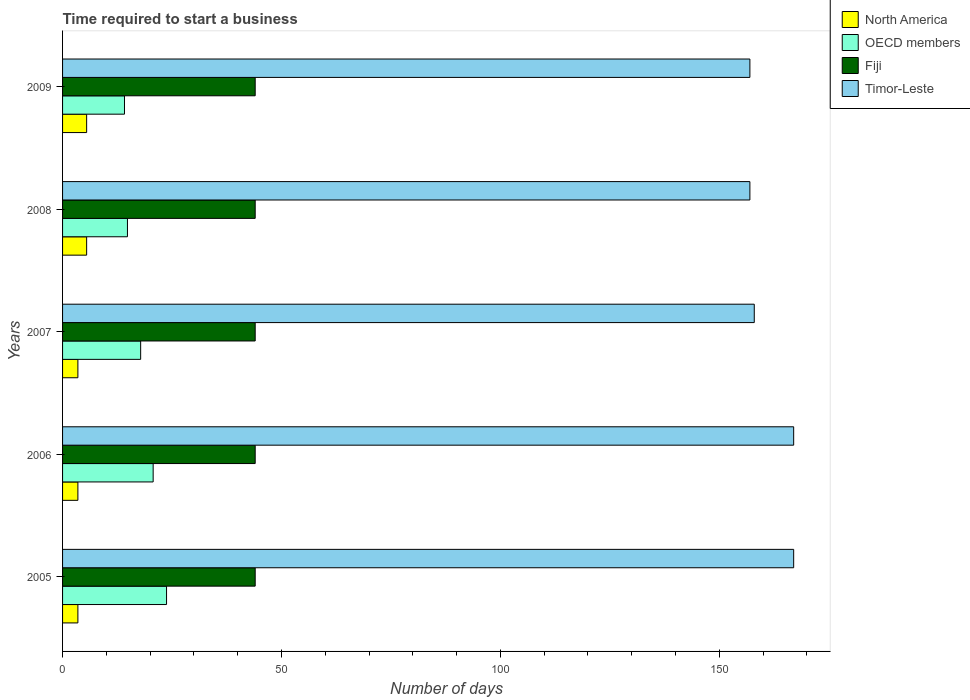How many different coloured bars are there?
Ensure brevity in your answer.  4. How many groups of bars are there?
Make the answer very short. 5. How many bars are there on the 5th tick from the top?
Provide a short and direct response. 4. What is the label of the 2nd group of bars from the top?
Your answer should be very brief. 2008. What is the number of days required to start a business in North America in 2008?
Your answer should be very brief. 5.5. Across all years, what is the maximum number of days required to start a business in Fiji?
Make the answer very short. 44. Across all years, what is the minimum number of days required to start a business in Fiji?
Your answer should be compact. 44. In which year was the number of days required to start a business in Fiji maximum?
Your answer should be compact. 2005. What is the total number of days required to start a business in Timor-Leste in the graph?
Your answer should be compact. 806. What is the difference between the number of days required to start a business in North America in 2005 and that in 2009?
Ensure brevity in your answer.  -2. What is the difference between the number of days required to start a business in OECD members in 2009 and the number of days required to start a business in Fiji in 2008?
Your answer should be very brief. -29.85. What is the average number of days required to start a business in Timor-Leste per year?
Provide a succinct answer. 161.2. In the year 2008, what is the difference between the number of days required to start a business in North America and number of days required to start a business in Timor-Leste?
Ensure brevity in your answer.  -151.5. In how many years, is the number of days required to start a business in Timor-Leste greater than 160 days?
Your answer should be very brief. 2. What is the ratio of the number of days required to start a business in OECD members in 2006 to that in 2007?
Ensure brevity in your answer.  1.16. Is the difference between the number of days required to start a business in North America in 2005 and 2007 greater than the difference between the number of days required to start a business in Timor-Leste in 2005 and 2007?
Ensure brevity in your answer.  No. What is the difference between the highest and the second highest number of days required to start a business in OECD members?
Offer a terse response. 3.06. What is the difference between the highest and the lowest number of days required to start a business in North America?
Your answer should be compact. 2. Is it the case that in every year, the sum of the number of days required to start a business in Fiji and number of days required to start a business in Timor-Leste is greater than the sum of number of days required to start a business in OECD members and number of days required to start a business in North America?
Give a very brief answer. No. What does the 1st bar from the top in 2007 represents?
Provide a succinct answer. Timor-Leste. What does the 4th bar from the bottom in 2006 represents?
Your response must be concise. Timor-Leste. Is it the case that in every year, the sum of the number of days required to start a business in North America and number of days required to start a business in OECD members is greater than the number of days required to start a business in Timor-Leste?
Your answer should be very brief. No. Are all the bars in the graph horizontal?
Your response must be concise. Yes. How many years are there in the graph?
Offer a terse response. 5. What is the difference between two consecutive major ticks on the X-axis?
Offer a terse response. 50. Does the graph contain any zero values?
Make the answer very short. No. Does the graph contain grids?
Provide a succinct answer. No. What is the title of the graph?
Provide a short and direct response. Time required to start a business. Does "Marshall Islands" appear as one of the legend labels in the graph?
Your response must be concise. No. What is the label or title of the X-axis?
Give a very brief answer. Number of days. What is the label or title of the Y-axis?
Provide a short and direct response. Years. What is the Number of days in OECD members in 2005?
Your answer should be compact. 23.75. What is the Number of days of Timor-Leste in 2005?
Provide a short and direct response. 167. What is the Number of days in OECD members in 2006?
Provide a succinct answer. 20.69. What is the Number of days in Fiji in 2006?
Make the answer very short. 44. What is the Number of days of Timor-Leste in 2006?
Keep it short and to the point. 167. What is the Number of days in North America in 2007?
Offer a very short reply. 3.5. What is the Number of days in OECD members in 2007?
Ensure brevity in your answer.  17.84. What is the Number of days in Fiji in 2007?
Your answer should be very brief. 44. What is the Number of days of Timor-Leste in 2007?
Make the answer very short. 158. What is the Number of days of OECD members in 2008?
Make the answer very short. 14.82. What is the Number of days in Fiji in 2008?
Keep it short and to the point. 44. What is the Number of days in Timor-Leste in 2008?
Provide a short and direct response. 157. What is the Number of days of OECD members in 2009?
Provide a short and direct response. 14.15. What is the Number of days of Timor-Leste in 2009?
Ensure brevity in your answer.  157. Across all years, what is the maximum Number of days in North America?
Your response must be concise. 5.5. Across all years, what is the maximum Number of days of OECD members?
Ensure brevity in your answer.  23.75. Across all years, what is the maximum Number of days in Timor-Leste?
Offer a very short reply. 167. Across all years, what is the minimum Number of days in OECD members?
Ensure brevity in your answer.  14.15. Across all years, what is the minimum Number of days in Timor-Leste?
Your response must be concise. 157. What is the total Number of days of North America in the graph?
Give a very brief answer. 21.5. What is the total Number of days in OECD members in the graph?
Provide a short and direct response. 91.25. What is the total Number of days in Fiji in the graph?
Ensure brevity in your answer.  220. What is the total Number of days of Timor-Leste in the graph?
Give a very brief answer. 806. What is the difference between the Number of days of OECD members in 2005 and that in 2006?
Offer a terse response. 3.06. What is the difference between the Number of days of Fiji in 2005 and that in 2006?
Offer a terse response. 0. What is the difference between the Number of days of Timor-Leste in 2005 and that in 2006?
Your answer should be very brief. 0. What is the difference between the Number of days of North America in 2005 and that in 2007?
Ensure brevity in your answer.  0. What is the difference between the Number of days in OECD members in 2005 and that in 2007?
Your answer should be very brief. 5.91. What is the difference between the Number of days of Fiji in 2005 and that in 2007?
Provide a succinct answer. 0. What is the difference between the Number of days in North America in 2005 and that in 2008?
Offer a very short reply. -2. What is the difference between the Number of days of OECD members in 2005 and that in 2008?
Your response must be concise. 8.93. What is the difference between the Number of days in Fiji in 2005 and that in 2008?
Ensure brevity in your answer.  0. What is the difference between the Number of days in Timor-Leste in 2005 and that in 2008?
Your answer should be very brief. 10. What is the difference between the Number of days in North America in 2005 and that in 2009?
Offer a terse response. -2. What is the difference between the Number of days in OECD members in 2005 and that in 2009?
Your answer should be very brief. 9.6. What is the difference between the Number of days in Fiji in 2005 and that in 2009?
Offer a terse response. 0. What is the difference between the Number of days of Timor-Leste in 2005 and that in 2009?
Your answer should be very brief. 10. What is the difference between the Number of days of North America in 2006 and that in 2007?
Your answer should be very brief. 0. What is the difference between the Number of days in OECD members in 2006 and that in 2007?
Your answer should be compact. 2.85. What is the difference between the Number of days of Timor-Leste in 2006 and that in 2007?
Your response must be concise. 9. What is the difference between the Number of days in OECD members in 2006 and that in 2008?
Provide a short and direct response. 5.87. What is the difference between the Number of days in Fiji in 2006 and that in 2008?
Your answer should be compact. 0. What is the difference between the Number of days in North America in 2006 and that in 2009?
Ensure brevity in your answer.  -2. What is the difference between the Number of days of OECD members in 2006 and that in 2009?
Your response must be concise. 6.55. What is the difference between the Number of days of Fiji in 2006 and that in 2009?
Offer a very short reply. 0. What is the difference between the Number of days in Timor-Leste in 2006 and that in 2009?
Your answer should be compact. 10. What is the difference between the Number of days of OECD members in 2007 and that in 2008?
Offer a terse response. 3.02. What is the difference between the Number of days in North America in 2007 and that in 2009?
Provide a succinct answer. -2. What is the difference between the Number of days of OECD members in 2007 and that in 2009?
Keep it short and to the point. 3.69. What is the difference between the Number of days in North America in 2008 and that in 2009?
Your answer should be very brief. 0. What is the difference between the Number of days of OECD members in 2008 and that in 2009?
Offer a very short reply. 0.68. What is the difference between the Number of days of Fiji in 2008 and that in 2009?
Give a very brief answer. 0. What is the difference between the Number of days of North America in 2005 and the Number of days of OECD members in 2006?
Give a very brief answer. -17.19. What is the difference between the Number of days in North America in 2005 and the Number of days in Fiji in 2006?
Ensure brevity in your answer.  -40.5. What is the difference between the Number of days of North America in 2005 and the Number of days of Timor-Leste in 2006?
Provide a succinct answer. -163.5. What is the difference between the Number of days in OECD members in 2005 and the Number of days in Fiji in 2006?
Provide a short and direct response. -20.25. What is the difference between the Number of days of OECD members in 2005 and the Number of days of Timor-Leste in 2006?
Your answer should be compact. -143.25. What is the difference between the Number of days of Fiji in 2005 and the Number of days of Timor-Leste in 2006?
Make the answer very short. -123. What is the difference between the Number of days of North America in 2005 and the Number of days of OECD members in 2007?
Your answer should be compact. -14.34. What is the difference between the Number of days in North America in 2005 and the Number of days in Fiji in 2007?
Offer a very short reply. -40.5. What is the difference between the Number of days in North America in 2005 and the Number of days in Timor-Leste in 2007?
Provide a short and direct response. -154.5. What is the difference between the Number of days of OECD members in 2005 and the Number of days of Fiji in 2007?
Ensure brevity in your answer.  -20.25. What is the difference between the Number of days in OECD members in 2005 and the Number of days in Timor-Leste in 2007?
Ensure brevity in your answer.  -134.25. What is the difference between the Number of days of Fiji in 2005 and the Number of days of Timor-Leste in 2007?
Offer a very short reply. -114. What is the difference between the Number of days in North America in 2005 and the Number of days in OECD members in 2008?
Offer a terse response. -11.32. What is the difference between the Number of days of North America in 2005 and the Number of days of Fiji in 2008?
Give a very brief answer. -40.5. What is the difference between the Number of days of North America in 2005 and the Number of days of Timor-Leste in 2008?
Offer a very short reply. -153.5. What is the difference between the Number of days in OECD members in 2005 and the Number of days in Fiji in 2008?
Your response must be concise. -20.25. What is the difference between the Number of days in OECD members in 2005 and the Number of days in Timor-Leste in 2008?
Your response must be concise. -133.25. What is the difference between the Number of days of Fiji in 2005 and the Number of days of Timor-Leste in 2008?
Your response must be concise. -113. What is the difference between the Number of days of North America in 2005 and the Number of days of OECD members in 2009?
Make the answer very short. -10.65. What is the difference between the Number of days of North America in 2005 and the Number of days of Fiji in 2009?
Provide a short and direct response. -40.5. What is the difference between the Number of days of North America in 2005 and the Number of days of Timor-Leste in 2009?
Your response must be concise. -153.5. What is the difference between the Number of days of OECD members in 2005 and the Number of days of Fiji in 2009?
Provide a succinct answer. -20.25. What is the difference between the Number of days of OECD members in 2005 and the Number of days of Timor-Leste in 2009?
Offer a very short reply. -133.25. What is the difference between the Number of days of Fiji in 2005 and the Number of days of Timor-Leste in 2009?
Provide a short and direct response. -113. What is the difference between the Number of days in North America in 2006 and the Number of days in OECD members in 2007?
Make the answer very short. -14.34. What is the difference between the Number of days of North America in 2006 and the Number of days of Fiji in 2007?
Offer a terse response. -40.5. What is the difference between the Number of days of North America in 2006 and the Number of days of Timor-Leste in 2007?
Make the answer very short. -154.5. What is the difference between the Number of days of OECD members in 2006 and the Number of days of Fiji in 2007?
Your response must be concise. -23.31. What is the difference between the Number of days in OECD members in 2006 and the Number of days in Timor-Leste in 2007?
Make the answer very short. -137.31. What is the difference between the Number of days in Fiji in 2006 and the Number of days in Timor-Leste in 2007?
Keep it short and to the point. -114. What is the difference between the Number of days in North America in 2006 and the Number of days in OECD members in 2008?
Ensure brevity in your answer.  -11.32. What is the difference between the Number of days of North America in 2006 and the Number of days of Fiji in 2008?
Make the answer very short. -40.5. What is the difference between the Number of days of North America in 2006 and the Number of days of Timor-Leste in 2008?
Your response must be concise. -153.5. What is the difference between the Number of days in OECD members in 2006 and the Number of days in Fiji in 2008?
Offer a terse response. -23.31. What is the difference between the Number of days of OECD members in 2006 and the Number of days of Timor-Leste in 2008?
Give a very brief answer. -136.31. What is the difference between the Number of days of Fiji in 2006 and the Number of days of Timor-Leste in 2008?
Offer a terse response. -113. What is the difference between the Number of days of North America in 2006 and the Number of days of OECD members in 2009?
Ensure brevity in your answer.  -10.65. What is the difference between the Number of days in North America in 2006 and the Number of days in Fiji in 2009?
Your answer should be compact. -40.5. What is the difference between the Number of days in North America in 2006 and the Number of days in Timor-Leste in 2009?
Make the answer very short. -153.5. What is the difference between the Number of days in OECD members in 2006 and the Number of days in Fiji in 2009?
Your answer should be compact. -23.31. What is the difference between the Number of days of OECD members in 2006 and the Number of days of Timor-Leste in 2009?
Ensure brevity in your answer.  -136.31. What is the difference between the Number of days of Fiji in 2006 and the Number of days of Timor-Leste in 2009?
Give a very brief answer. -113. What is the difference between the Number of days in North America in 2007 and the Number of days in OECD members in 2008?
Provide a succinct answer. -11.32. What is the difference between the Number of days in North America in 2007 and the Number of days in Fiji in 2008?
Offer a terse response. -40.5. What is the difference between the Number of days of North America in 2007 and the Number of days of Timor-Leste in 2008?
Make the answer very short. -153.5. What is the difference between the Number of days in OECD members in 2007 and the Number of days in Fiji in 2008?
Provide a short and direct response. -26.16. What is the difference between the Number of days of OECD members in 2007 and the Number of days of Timor-Leste in 2008?
Give a very brief answer. -139.16. What is the difference between the Number of days of Fiji in 2007 and the Number of days of Timor-Leste in 2008?
Provide a short and direct response. -113. What is the difference between the Number of days of North America in 2007 and the Number of days of OECD members in 2009?
Provide a succinct answer. -10.65. What is the difference between the Number of days in North America in 2007 and the Number of days in Fiji in 2009?
Make the answer very short. -40.5. What is the difference between the Number of days of North America in 2007 and the Number of days of Timor-Leste in 2009?
Your response must be concise. -153.5. What is the difference between the Number of days in OECD members in 2007 and the Number of days in Fiji in 2009?
Provide a succinct answer. -26.16. What is the difference between the Number of days of OECD members in 2007 and the Number of days of Timor-Leste in 2009?
Offer a terse response. -139.16. What is the difference between the Number of days in Fiji in 2007 and the Number of days in Timor-Leste in 2009?
Make the answer very short. -113. What is the difference between the Number of days in North America in 2008 and the Number of days in OECD members in 2009?
Your answer should be compact. -8.65. What is the difference between the Number of days of North America in 2008 and the Number of days of Fiji in 2009?
Provide a short and direct response. -38.5. What is the difference between the Number of days of North America in 2008 and the Number of days of Timor-Leste in 2009?
Give a very brief answer. -151.5. What is the difference between the Number of days in OECD members in 2008 and the Number of days in Fiji in 2009?
Your answer should be very brief. -29.18. What is the difference between the Number of days in OECD members in 2008 and the Number of days in Timor-Leste in 2009?
Offer a very short reply. -142.18. What is the difference between the Number of days of Fiji in 2008 and the Number of days of Timor-Leste in 2009?
Offer a very short reply. -113. What is the average Number of days of OECD members per year?
Give a very brief answer. 18.25. What is the average Number of days of Timor-Leste per year?
Your answer should be very brief. 161.2. In the year 2005, what is the difference between the Number of days of North America and Number of days of OECD members?
Provide a short and direct response. -20.25. In the year 2005, what is the difference between the Number of days of North America and Number of days of Fiji?
Offer a very short reply. -40.5. In the year 2005, what is the difference between the Number of days of North America and Number of days of Timor-Leste?
Offer a terse response. -163.5. In the year 2005, what is the difference between the Number of days of OECD members and Number of days of Fiji?
Ensure brevity in your answer.  -20.25. In the year 2005, what is the difference between the Number of days in OECD members and Number of days in Timor-Leste?
Keep it short and to the point. -143.25. In the year 2005, what is the difference between the Number of days in Fiji and Number of days in Timor-Leste?
Your answer should be very brief. -123. In the year 2006, what is the difference between the Number of days of North America and Number of days of OECD members?
Keep it short and to the point. -17.19. In the year 2006, what is the difference between the Number of days in North America and Number of days in Fiji?
Ensure brevity in your answer.  -40.5. In the year 2006, what is the difference between the Number of days of North America and Number of days of Timor-Leste?
Provide a short and direct response. -163.5. In the year 2006, what is the difference between the Number of days in OECD members and Number of days in Fiji?
Provide a short and direct response. -23.31. In the year 2006, what is the difference between the Number of days in OECD members and Number of days in Timor-Leste?
Offer a very short reply. -146.31. In the year 2006, what is the difference between the Number of days in Fiji and Number of days in Timor-Leste?
Ensure brevity in your answer.  -123. In the year 2007, what is the difference between the Number of days in North America and Number of days in OECD members?
Provide a short and direct response. -14.34. In the year 2007, what is the difference between the Number of days in North America and Number of days in Fiji?
Provide a short and direct response. -40.5. In the year 2007, what is the difference between the Number of days of North America and Number of days of Timor-Leste?
Make the answer very short. -154.5. In the year 2007, what is the difference between the Number of days of OECD members and Number of days of Fiji?
Offer a very short reply. -26.16. In the year 2007, what is the difference between the Number of days of OECD members and Number of days of Timor-Leste?
Provide a short and direct response. -140.16. In the year 2007, what is the difference between the Number of days of Fiji and Number of days of Timor-Leste?
Your answer should be very brief. -114. In the year 2008, what is the difference between the Number of days in North America and Number of days in OECD members?
Make the answer very short. -9.32. In the year 2008, what is the difference between the Number of days of North America and Number of days of Fiji?
Provide a succinct answer. -38.5. In the year 2008, what is the difference between the Number of days of North America and Number of days of Timor-Leste?
Offer a terse response. -151.5. In the year 2008, what is the difference between the Number of days of OECD members and Number of days of Fiji?
Provide a short and direct response. -29.18. In the year 2008, what is the difference between the Number of days of OECD members and Number of days of Timor-Leste?
Offer a very short reply. -142.18. In the year 2008, what is the difference between the Number of days of Fiji and Number of days of Timor-Leste?
Provide a short and direct response. -113. In the year 2009, what is the difference between the Number of days of North America and Number of days of OECD members?
Offer a very short reply. -8.65. In the year 2009, what is the difference between the Number of days of North America and Number of days of Fiji?
Keep it short and to the point. -38.5. In the year 2009, what is the difference between the Number of days of North America and Number of days of Timor-Leste?
Keep it short and to the point. -151.5. In the year 2009, what is the difference between the Number of days of OECD members and Number of days of Fiji?
Offer a terse response. -29.85. In the year 2009, what is the difference between the Number of days of OECD members and Number of days of Timor-Leste?
Give a very brief answer. -142.85. In the year 2009, what is the difference between the Number of days in Fiji and Number of days in Timor-Leste?
Provide a short and direct response. -113. What is the ratio of the Number of days of OECD members in 2005 to that in 2006?
Ensure brevity in your answer.  1.15. What is the ratio of the Number of days in North America in 2005 to that in 2007?
Offer a very short reply. 1. What is the ratio of the Number of days in OECD members in 2005 to that in 2007?
Your answer should be compact. 1.33. What is the ratio of the Number of days in Timor-Leste in 2005 to that in 2007?
Your answer should be compact. 1.06. What is the ratio of the Number of days of North America in 2005 to that in 2008?
Offer a very short reply. 0.64. What is the ratio of the Number of days of OECD members in 2005 to that in 2008?
Provide a succinct answer. 1.6. What is the ratio of the Number of days of Fiji in 2005 to that in 2008?
Your response must be concise. 1. What is the ratio of the Number of days of Timor-Leste in 2005 to that in 2008?
Keep it short and to the point. 1.06. What is the ratio of the Number of days of North America in 2005 to that in 2009?
Offer a very short reply. 0.64. What is the ratio of the Number of days of OECD members in 2005 to that in 2009?
Keep it short and to the point. 1.68. What is the ratio of the Number of days in Timor-Leste in 2005 to that in 2009?
Make the answer very short. 1.06. What is the ratio of the Number of days of OECD members in 2006 to that in 2007?
Offer a terse response. 1.16. What is the ratio of the Number of days in Fiji in 2006 to that in 2007?
Provide a succinct answer. 1. What is the ratio of the Number of days of Timor-Leste in 2006 to that in 2007?
Offer a terse response. 1.06. What is the ratio of the Number of days in North America in 2006 to that in 2008?
Give a very brief answer. 0.64. What is the ratio of the Number of days in OECD members in 2006 to that in 2008?
Make the answer very short. 1.4. What is the ratio of the Number of days in Fiji in 2006 to that in 2008?
Your response must be concise. 1. What is the ratio of the Number of days of Timor-Leste in 2006 to that in 2008?
Ensure brevity in your answer.  1.06. What is the ratio of the Number of days of North America in 2006 to that in 2009?
Your response must be concise. 0.64. What is the ratio of the Number of days of OECD members in 2006 to that in 2009?
Offer a very short reply. 1.46. What is the ratio of the Number of days in Timor-Leste in 2006 to that in 2009?
Make the answer very short. 1.06. What is the ratio of the Number of days of North America in 2007 to that in 2008?
Your answer should be compact. 0.64. What is the ratio of the Number of days of OECD members in 2007 to that in 2008?
Your answer should be very brief. 1.2. What is the ratio of the Number of days in Fiji in 2007 to that in 2008?
Your answer should be compact. 1. What is the ratio of the Number of days of Timor-Leste in 2007 to that in 2008?
Ensure brevity in your answer.  1.01. What is the ratio of the Number of days in North America in 2007 to that in 2009?
Make the answer very short. 0.64. What is the ratio of the Number of days of OECD members in 2007 to that in 2009?
Keep it short and to the point. 1.26. What is the ratio of the Number of days in Timor-Leste in 2007 to that in 2009?
Provide a succinct answer. 1.01. What is the ratio of the Number of days of North America in 2008 to that in 2009?
Provide a short and direct response. 1. What is the ratio of the Number of days of OECD members in 2008 to that in 2009?
Your response must be concise. 1.05. What is the ratio of the Number of days in Timor-Leste in 2008 to that in 2009?
Ensure brevity in your answer.  1. What is the difference between the highest and the second highest Number of days of OECD members?
Provide a succinct answer. 3.06. What is the difference between the highest and the lowest Number of days in OECD members?
Give a very brief answer. 9.6. What is the difference between the highest and the lowest Number of days in Fiji?
Your response must be concise. 0. What is the difference between the highest and the lowest Number of days in Timor-Leste?
Keep it short and to the point. 10. 